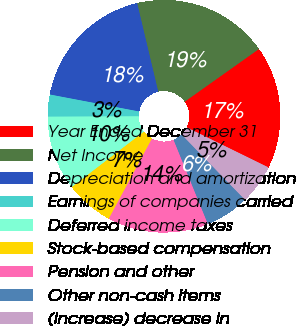<chart> <loc_0><loc_0><loc_500><loc_500><pie_chart><fcel>Year Ended December 31<fcel>Net Income<fcel>Depreciation and amortization<fcel>Earnings of companies carried<fcel>Deferred income taxes<fcel>Stock-based compensation<fcel>Pension and other<fcel>Other non-cash items<fcel>(Increase) decrease in<nl><fcel>17.07%<fcel>18.9%<fcel>18.29%<fcel>3.05%<fcel>10.37%<fcel>6.71%<fcel>14.02%<fcel>6.1%<fcel>5.49%<nl></chart> 